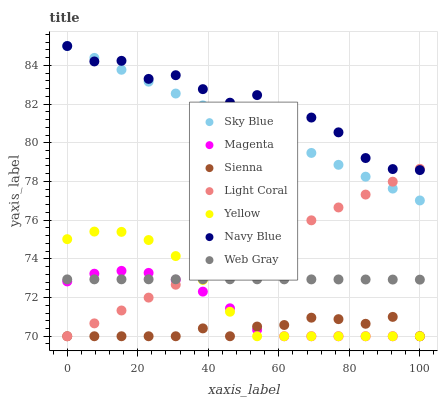Does Sienna have the minimum area under the curve?
Answer yes or no. Yes. Does Navy Blue have the maximum area under the curve?
Answer yes or no. Yes. Does Web Gray have the minimum area under the curve?
Answer yes or no. No. Does Web Gray have the maximum area under the curve?
Answer yes or no. No. Is Sky Blue the smoothest?
Answer yes or no. Yes. Is Navy Blue the roughest?
Answer yes or no. Yes. Is Web Gray the smoothest?
Answer yes or no. No. Is Web Gray the roughest?
Answer yes or no. No. Does Light Coral have the lowest value?
Answer yes or no. Yes. Does Web Gray have the lowest value?
Answer yes or no. No. Does Sky Blue have the highest value?
Answer yes or no. Yes. Does Web Gray have the highest value?
Answer yes or no. No. Is Web Gray less than Sky Blue?
Answer yes or no. Yes. Is Navy Blue greater than Magenta?
Answer yes or no. Yes. Does Light Coral intersect Yellow?
Answer yes or no. Yes. Is Light Coral less than Yellow?
Answer yes or no. No. Is Light Coral greater than Yellow?
Answer yes or no. No. Does Web Gray intersect Sky Blue?
Answer yes or no. No. 